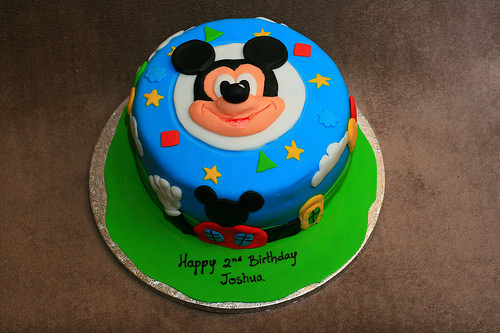<image>
Is the star above the mouse? Yes. The star is positioned above the mouse in the vertical space, higher up in the scene. 